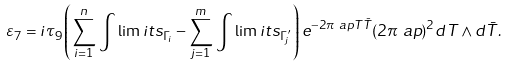<formula> <loc_0><loc_0><loc_500><loc_500>\varepsilon _ { 7 } & = i \tau _ { 9 } \left ( \sum _ { i = 1 } ^ { n } \, \int \lim i t s _ { \Gamma _ { i } } - \sum _ { j = 1 } ^ { m } \, \int \lim i t s _ { \Gamma _ { j } ^ { \prime } } \right ) e ^ { - 2 \pi \ a p T \bar { T } } ( 2 \pi \ a p ) ^ { 2 } d T \wedge d \bar { T } .</formula> 